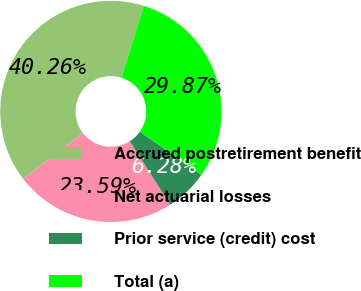<chart> <loc_0><loc_0><loc_500><loc_500><pie_chart><fcel>Accrued postretirement benefit<fcel>Net actuarial losses<fcel>Prior service (credit) cost<fcel>Total (a)<nl><fcel>40.26%<fcel>23.59%<fcel>6.28%<fcel>29.87%<nl></chart> 